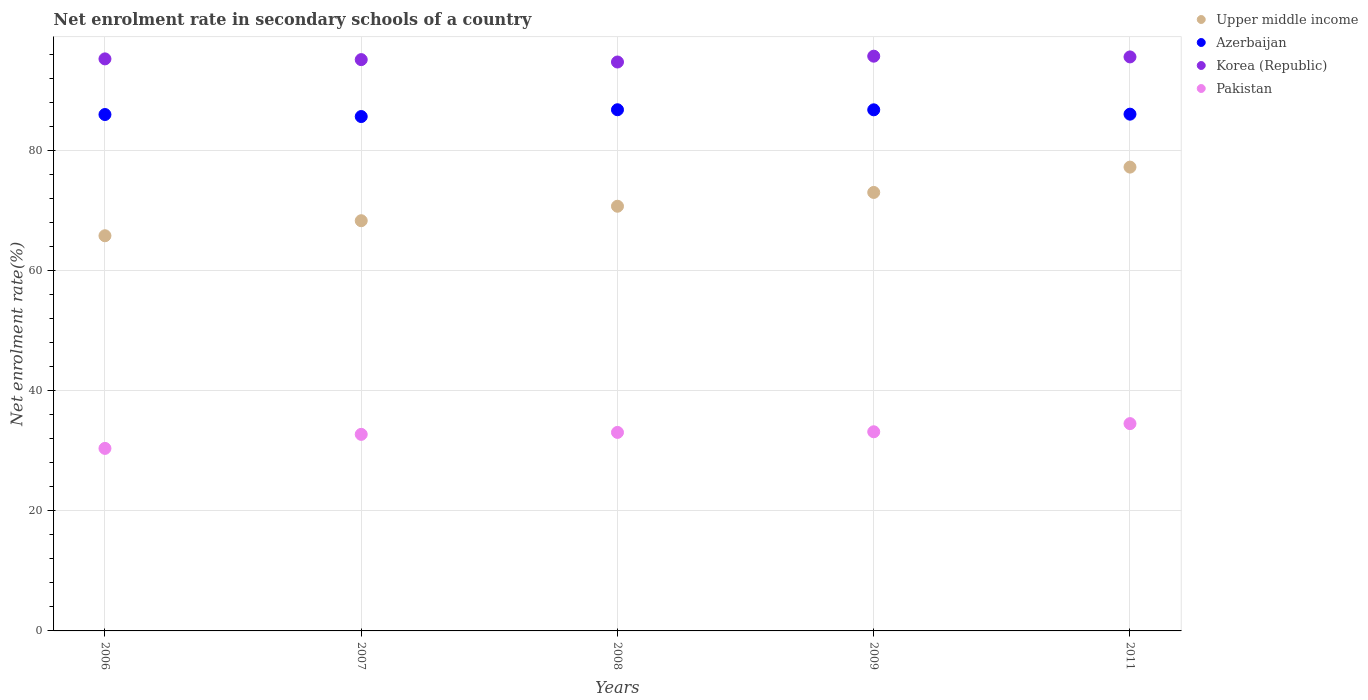Is the number of dotlines equal to the number of legend labels?
Make the answer very short. Yes. What is the net enrolment rate in secondary schools in Korea (Republic) in 2006?
Your answer should be compact. 95.28. Across all years, what is the maximum net enrolment rate in secondary schools in Korea (Republic)?
Your response must be concise. 95.73. Across all years, what is the minimum net enrolment rate in secondary schools in Upper middle income?
Ensure brevity in your answer.  65.82. In which year was the net enrolment rate in secondary schools in Pakistan maximum?
Give a very brief answer. 2011. What is the total net enrolment rate in secondary schools in Azerbaijan in the graph?
Provide a short and direct response. 431.38. What is the difference between the net enrolment rate in secondary schools in Pakistan in 2008 and that in 2011?
Ensure brevity in your answer.  -1.46. What is the difference between the net enrolment rate in secondary schools in Pakistan in 2011 and the net enrolment rate in secondary schools in Korea (Republic) in 2008?
Your response must be concise. -60.23. What is the average net enrolment rate in secondary schools in Azerbaijan per year?
Provide a short and direct response. 86.28. In the year 2006, what is the difference between the net enrolment rate in secondary schools in Upper middle income and net enrolment rate in secondary schools in Pakistan?
Your response must be concise. 35.42. What is the ratio of the net enrolment rate in secondary schools in Upper middle income in 2008 to that in 2011?
Provide a short and direct response. 0.92. What is the difference between the highest and the second highest net enrolment rate in secondary schools in Upper middle income?
Provide a succinct answer. 4.22. What is the difference between the highest and the lowest net enrolment rate in secondary schools in Azerbaijan?
Give a very brief answer. 1.13. Is it the case that in every year, the sum of the net enrolment rate in secondary schools in Pakistan and net enrolment rate in secondary schools in Upper middle income  is greater than the sum of net enrolment rate in secondary schools in Korea (Republic) and net enrolment rate in secondary schools in Azerbaijan?
Your answer should be compact. Yes. Is it the case that in every year, the sum of the net enrolment rate in secondary schools in Upper middle income and net enrolment rate in secondary schools in Korea (Republic)  is greater than the net enrolment rate in secondary schools in Pakistan?
Give a very brief answer. Yes. How many years are there in the graph?
Ensure brevity in your answer.  5. What is the difference between two consecutive major ticks on the Y-axis?
Provide a succinct answer. 20. Does the graph contain any zero values?
Offer a terse response. No. Does the graph contain grids?
Your answer should be compact. Yes. How are the legend labels stacked?
Provide a succinct answer. Vertical. What is the title of the graph?
Offer a very short reply. Net enrolment rate in secondary schools of a country. Does "Malawi" appear as one of the legend labels in the graph?
Your answer should be compact. No. What is the label or title of the Y-axis?
Make the answer very short. Net enrolment rate(%). What is the Net enrolment rate(%) of Upper middle income in 2006?
Your answer should be very brief. 65.82. What is the Net enrolment rate(%) in Azerbaijan in 2006?
Give a very brief answer. 86.02. What is the Net enrolment rate(%) in Korea (Republic) in 2006?
Give a very brief answer. 95.28. What is the Net enrolment rate(%) of Pakistan in 2006?
Give a very brief answer. 30.4. What is the Net enrolment rate(%) of Upper middle income in 2007?
Keep it short and to the point. 68.33. What is the Net enrolment rate(%) in Azerbaijan in 2007?
Keep it short and to the point. 85.68. What is the Net enrolment rate(%) of Korea (Republic) in 2007?
Give a very brief answer. 95.16. What is the Net enrolment rate(%) in Pakistan in 2007?
Offer a very short reply. 32.74. What is the Net enrolment rate(%) in Upper middle income in 2008?
Offer a terse response. 70.74. What is the Net enrolment rate(%) of Azerbaijan in 2008?
Ensure brevity in your answer.  86.81. What is the Net enrolment rate(%) of Korea (Republic) in 2008?
Offer a terse response. 94.76. What is the Net enrolment rate(%) in Pakistan in 2008?
Your answer should be compact. 33.06. What is the Net enrolment rate(%) of Upper middle income in 2009?
Offer a terse response. 73.04. What is the Net enrolment rate(%) in Azerbaijan in 2009?
Provide a short and direct response. 86.8. What is the Net enrolment rate(%) of Korea (Republic) in 2009?
Your answer should be very brief. 95.73. What is the Net enrolment rate(%) of Pakistan in 2009?
Give a very brief answer. 33.17. What is the Net enrolment rate(%) in Upper middle income in 2011?
Ensure brevity in your answer.  77.26. What is the Net enrolment rate(%) of Azerbaijan in 2011?
Offer a terse response. 86.07. What is the Net enrolment rate(%) of Korea (Republic) in 2011?
Provide a succinct answer. 95.61. What is the Net enrolment rate(%) of Pakistan in 2011?
Your response must be concise. 34.53. Across all years, what is the maximum Net enrolment rate(%) in Upper middle income?
Your response must be concise. 77.26. Across all years, what is the maximum Net enrolment rate(%) of Azerbaijan?
Your answer should be very brief. 86.81. Across all years, what is the maximum Net enrolment rate(%) in Korea (Republic)?
Keep it short and to the point. 95.73. Across all years, what is the maximum Net enrolment rate(%) of Pakistan?
Ensure brevity in your answer.  34.53. Across all years, what is the minimum Net enrolment rate(%) of Upper middle income?
Your answer should be compact. 65.82. Across all years, what is the minimum Net enrolment rate(%) in Azerbaijan?
Make the answer very short. 85.68. Across all years, what is the minimum Net enrolment rate(%) of Korea (Republic)?
Your response must be concise. 94.76. Across all years, what is the minimum Net enrolment rate(%) of Pakistan?
Your answer should be very brief. 30.4. What is the total Net enrolment rate(%) in Upper middle income in the graph?
Offer a very short reply. 355.18. What is the total Net enrolment rate(%) of Azerbaijan in the graph?
Make the answer very short. 431.38. What is the total Net enrolment rate(%) of Korea (Republic) in the graph?
Your answer should be very brief. 476.55. What is the total Net enrolment rate(%) of Pakistan in the graph?
Keep it short and to the point. 163.91. What is the difference between the Net enrolment rate(%) of Upper middle income in 2006 and that in 2007?
Offer a terse response. -2.5. What is the difference between the Net enrolment rate(%) in Azerbaijan in 2006 and that in 2007?
Provide a short and direct response. 0.34. What is the difference between the Net enrolment rate(%) in Korea (Republic) in 2006 and that in 2007?
Give a very brief answer. 0.12. What is the difference between the Net enrolment rate(%) in Pakistan in 2006 and that in 2007?
Offer a very short reply. -2.34. What is the difference between the Net enrolment rate(%) of Upper middle income in 2006 and that in 2008?
Offer a very short reply. -4.92. What is the difference between the Net enrolment rate(%) of Azerbaijan in 2006 and that in 2008?
Your answer should be very brief. -0.79. What is the difference between the Net enrolment rate(%) in Korea (Republic) in 2006 and that in 2008?
Offer a very short reply. 0.52. What is the difference between the Net enrolment rate(%) in Pakistan in 2006 and that in 2008?
Provide a succinct answer. -2.66. What is the difference between the Net enrolment rate(%) of Upper middle income in 2006 and that in 2009?
Offer a very short reply. -7.21. What is the difference between the Net enrolment rate(%) of Azerbaijan in 2006 and that in 2009?
Ensure brevity in your answer.  -0.78. What is the difference between the Net enrolment rate(%) of Korea (Republic) in 2006 and that in 2009?
Your answer should be very brief. -0.45. What is the difference between the Net enrolment rate(%) of Pakistan in 2006 and that in 2009?
Your answer should be very brief. -2.77. What is the difference between the Net enrolment rate(%) in Upper middle income in 2006 and that in 2011?
Your response must be concise. -11.43. What is the difference between the Net enrolment rate(%) of Azerbaijan in 2006 and that in 2011?
Offer a very short reply. -0.06. What is the difference between the Net enrolment rate(%) in Korea (Republic) in 2006 and that in 2011?
Offer a very short reply. -0.33. What is the difference between the Net enrolment rate(%) in Pakistan in 2006 and that in 2011?
Make the answer very short. -4.13. What is the difference between the Net enrolment rate(%) of Upper middle income in 2007 and that in 2008?
Ensure brevity in your answer.  -2.41. What is the difference between the Net enrolment rate(%) in Azerbaijan in 2007 and that in 2008?
Provide a succinct answer. -1.13. What is the difference between the Net enrolment rate(%) in Korea (Republic) in 2007 and that in 2008?
Give a very brief answer. 0.4. What is the difference between the Net enrolment rate(%) in Pakistan in 2007 and that in 2008?
Your response must be concise. -0.33. What is the difference between the Net enrolment rate(%) in Upper middle income in 2007 and that in 2009?
Offer a very short reply. -4.71. What is the difference between the Net enrolment rate(%) in Azerbaijan in 2007 and that in 2009?
Your response must be concise. -1.12. What is the difference between the Net enrolment rate(%) in Korea (Republic) in 2007 and that in 2009?
Keep it short and to the point. -0.57. What is the difference between the Net enrolment rate(%) of Pakistan in 2007 and that in 2009?
Offer a very short reply. -0.43. What is the difference between the Net enrolment rate(%) in Upper middle income in 2007 and that in 2011?
Ensure brevity in your answer.  -8.93. What is the difference between the Net enrolment rate(%) of Azerbaijan in 2007 and that in 2011?
Make the answer very short. -0.4. What is the difference between the Net enrolment rate(%) in Korea (Republic) in 2007 and that in 2011?
Ensure brevity in your answer.  -0.45. What is the difference between the Net enrolment rate(%) of Pakistan in 2007 and that in 2011?
Your answer should be very brief. -1.79. What is the difference between the Net enrolment rate(%) in Upper middle income in 2008 and that in 2009?
Your answer should be compact. -2.3. What is the difference between the Net enrolment rate(%) of Azerbaijan in 2008 and that in 2009?
Offer a terse response. 0.01. What is the difference between the Net enrolment rate(%) of Korea (Republic) in 2008 and that in 2009?
Your answer should be very brief. -0.97. What is the difference between the Net enrolment rate(%) in Pakistan in 2008 and that in 2009?
Your response must be concise. -0.11. What is the difference between the Net enrolment rate(%) in Upper middle income in 2008 and that in 2011?
Provide a succinct answer. -6.52. What is the difference between the Net enrolment rate(%) in Azerbaijan in 2008 and that in 2011?
Your response must be concise. 0.74. What is the difference between the Net enrolment rate(%) in Korea (Republic) in 2008 and that in 2011?
Offer a terse response. -0.85. What is the difference between the Net enrolment rate(%) in Pakistan in 2008 and that in 2011?
Your answer should be compact. -1.46. What is the difference between the Net enrolment rate(%) of Upper middle income in 2009 and that in 2011?
Offer a terse response. -4.22. What is the difference between the Net enrolment rate(%) of Azerbaijan in 2009 and that in 2011?
Provide a short and direct response. 0.72. What is the difference between the Net enrolment rate(%) of Korea (Republic) in 2009 and that in 2011?
Give a very brief answer. 0.12. What is the difference between the Net enrolment rate(%) in Pakistan in 2009 and that in 2011?
Your answer should be compact. -1.36. What is the difference between the Net enrolment rate(%) in Upper middle income in 2006 and the Net enrolment rate(%) in Azerbaijan in 2007?
Your answer should be compact. -19.86. What is the difference between the Net enrolment rate(%) of Upper middle income in 2006 and the Net enrolment rate(%) of Korea (Republic) in 2007?
Your response must be concise. -29.34. What is the difference between the Net enrolment rate(%) of Upper middle income in 2006 and the Net enrolment rate(%) of Pakistan in 2007?
Offer a terse response. 33.08. What is the difference between the Net enrolment rate(%) of Azerbaijan in 2006 and the Net enrolment rate(%) of Korea (Republic) in 2007?
Provide a short and direct response. -9.14. What is the difference between the Net enrolment rate(%) in Azerbaijan in 2006 and the Net enrolment rate(%) in Pakistan in 2007?
Provide a succinct answer. 53.28. What is the difference between the Net enrolment rate(%) in Korea (Republic) in 2006 and the Net enrolment rate(%) in Pakistan in 2007?
Give a very brief answer. 62.54. What is the difference between the Net enrolment rate(%) of Upper middle income in 2006 and the Net enrolment rate(%) of Azerbaijan in 2008?
Offer a terse response. -20.99. What is the difference between the Net enrolment rate(%) in Upper middle income in 2006 and the Net enrolment rate(%) in Korea (Republic) in 2008?
Keep it short and to the point. -28.94. What is the difference between the Net enrolment rate(%) of Upper middle income in 2006 and the Net enrolment rate(%) of Pakistan in 2008?
Ensure brevity in your answer.  32.76. What is the difference between the Net enrolment rate(%) in Azerbaijan in 2006 and the Net enrolment rate(%) in Korea (Republic) in 2008?
Give a very brief answer. -8.75. What is the difference between the Net enrolment rate(%) of Azerbaijan in 2006 and the Net enrolment rate(%) of Pakistan in 2008?
Make the answer very short. 52.95. What is the difference between the Net enrolment rate(%) in Korea (Republic) in 2006 and the Net enrolment rate(%) in Pakistan in 2008?
Provide a succinct answer. 62.22. What is the difference between the Net enrolment rate(%) in Upper middle income in 2006 and the Net enrolment rate(%) in Azerbaijan in 2009?
Provide a succinct answer. -20.98. What is the difference between the Net enrolment rate(%) in Upper middle income in 2006 and the Net enrolment rate(%) in Korea (Republic) in 2009?
Provide a short and direct response. -29.91. What is the difference between the Net enrolment rate(%) in Upper middle income in 2006 and the Net enrolment rate(%) in Pakistan in 2009?
Your answer should be very brief. 32.65. What is the difference between the Net enrolment rate(%) in Azerbaijan in 2006 and the Net enrolment rate(%) in Korea (Republic) in 2009?
Ensure brevity in your answer.  -9.72. What is the difference between the Net enrolment rate(%) of Azerbaijan in 2006 and the Net enrolment rate(%) of Pakistan in 2009?
Provide a succinct answer. 52.84. What is the difference between the Net enrolment rate(%) of Korea (Republic) in 2006 and the Net enrolment rate(%) of Pakistan in 2009?
Keep it short and to the point. 62.11. What is the difference between the Net enrolment rate(%) in Upper middle income in 2006 and the Net enrolment rate(%) in Azerbaijan in 2011?
Give a very brief answer. -20.25. What is the difference between the Net enrolment rate(%) of Upper middle income in 2006 and the Net enrolment rate(%) of Korea (Republic) in 2011?
Make the answer very short. -29.79. What is the difference between the Net enrolment rate(%) in Upper middle income in 2006 and the Net enrolment rate(%) in Pakistan in 2011?
Provide a short and direct response. 31.29. What is the difference between the Net enrolment rate(%) of Azerbaijan in 2006 and the Net enrolment rate(%) of Korea (Republic) in 2011?
Offer a terse response. -9.59. What is the difference between the Net enrolment rate(%) in Azerbaijan in 2006 and the Net enrolment rate(%) in Pakistan in 2011?
Keep it short and to the point. 51.49. What is the difference between the Net enrolment rate(%) in Korea (Republic) in 2006 and the Net enrolment rate(%) in Pakistan in 2011?
Your answer should be very brief. 60.75. What is the difference between the Net enrolment rate(%) of Upper middle income in 2007 and the Net enrolment rate(%) of Azerbaijan in 2008?
Your response must be concise. -18.48. What is the difference between the Net enrolment rate(%) of Upper middle income in 2007 and the Net enrolment rate(%) of Korea (Republic) in 2008?
Your answer should be very brief. -26.44. What is the difference between the Net enrolment rate(%) of Upper middle income in 2007 and the Net enrolment rate(%) of Pakistan in 2008?
Your answer should be very brief. 35.26. What is the difference between the Net enrolment rate(%) in Azerbaijan in 2007 and the Net enrolment rate(%) in Korea (Republic) in 2008?
Offer a terse response. -9.08. What is the difference between the Net enrolment rate(%) of Azerbaijan in 2007 and the Net enrolment rate(%) of Pakistan in 2008?
Provide a succinct answer. 52.61. What is the difference between the Net enrolment rate(%) of Korea (Republic) in 2007 and the Net enrolment rate(%) of Pakistan in 2008?
Your answer should be very brief. 62.1. What is the difference between the Net enrolment rate(%) of Upper middle income in 2007 and the Net enrolment rate(%) of Azerbaijan in 2009?
Provide a short and direct response. -18.47. What is the difference between the Net enrolment rate(%) in Upper middle income in 2007 and the Net enrolment rate(%) in Korea (Republic) in 2009?
Your answer should be very brief. -27.41. What is the difference between the Net enrolment rate(%) in Upper middle income in 2007 and the Net enrolment rate(%) in Pakistan in 2009?
Your answer should be very brief. 35.16. What is the difference between the Net enrolment rate(%) of Azerbaijan in 2007 and the Net enrolment rate(%) of Korea (Republic) in 2009?
Offer a very short reply. -10.05. What is the difference between the Net enrolment rate(%) of Azerbaijan in 2007 and the Net enrolment rate(%) of Pakistan in 2009?
Your response must be concise. 52.51. What is the difference between the Net enrolment rate(%) of Korea (Republic) in 2007 and the Net enrolment rate(%) of Pakistan in 2009?
Offer a very short reply. 61.99. What is the difference between the Net enrolment rate(%) in Upper middle income in 2007 and the Net enrolment rate(%) in Azerbaijan in 2011?
Give a very brief answer. -17.75. What is the difference between the Net enrolment rate(%) in Upper middle income in 2007 and the Net enrolment rate(%) in Korea (Republic) in 2011?
Offer a terse response. -27.28. What is the difference between the Net enrolment rate(%) in Upper middle income in 2007 and the Net enrolment rate(%) in Pakistan in 2011?
Keep it short and to the point. 33.8. What is the difference between the Net enrolment rate(%) of Azerbaijan in 2007 and the Net enrolment rate(%) of Korea (Republic) in 2011?
Make the answer very short. -9.93. What is the difference between the Net enrolment rate(%) in Azerbaijan in 2007 and the Net enrolment rate(%) in Pakistan in 2011?
Your answer should be compact. 51.15. What is the difference between the Net enrolment rate(%) in Korea (Republic) in 2007 and the Net enrolment rate(%) in Pakistan in 2011?
Your answer should be very brief. 60.63. What is the difference between the Net enrolment rate(%) in Upper middle income in 2008 and the Net enrolment rate(%) in Azerbaijan in 2009?
Your answer should be compact. -16.06. What is the difference between the Net enrolment rate(%) of Upper middle income in 2008 and the Net enrolment rate(%) of Korea (Republic) in 2009?
Ensure brevity in your answer.  -24.99. What is the difference between the Net enrolment rate(%) in Upper middle income in 2008 and the Net enrolment rate(%) in Pakistan in 2009?
Ensure brevity in your answer.  37.57. What is the difference between the Net enrolment rate(%) in Azerbaijan in 2008 and the Net enrolment rate(%) in Korea (Republic) in 2009?
Offer a terse response. -8.92. What is the difference between the Net enrolment rate(%) in Azerbaijan in 2008 and the Net enrolment rate(%) in Pakistan in 2009?
Keep it short and to the point. 53.64. What is the difference between the Net enrolment rate(%) in Korea (Republic) in 2008 and the Net enrolment rate(%) in Pakistan in 2009?
Provide a succinct answer. 61.59. What is the difference between the Net enrolment rate(%) of Upper middle income in 2008 and the Net enrolment rate(%) of Azerbaijan in 2011?
Offer a terse response. -15.34. What is the difference between the Net enrolment rate(%) in Upper middle income in 2008 and the Net enrolment rate(%) in Korea (Republic) in 2011?
Offer a terse response. -24.87. What is the difference between the Net enrolment rate(%) of Upper middle income in 2008 and the Net enrolment rate(%) of Pakistan in 2011?
Provide a succinct answer. 36.21. What is the difference between the Net enrolment rate(%) of Azerbaijan in 2008 and the Net enrolment rate(%) of Korea (Republic) in 2011?
Offer a very short reply. -8.8. What is the difference between the Net enrolment rate(%) in Azerbaijan in 2008 and the Net enrolment rate(%) in Pakistan in 2011?
Offer a terse response. 52.28. What is the difference between the Net enrolment rate(%) in Korea (Republic) in 2008 and the Net enrolment rate(%) in Pakistan in 2011?
Give a very brief answer. 60.23. What is the difference between the Net enrolment rate(%) of Upper middle income in 2009 and the Net enrolment rate(%) of Azerbaijan in 2011?
Ensure brevity in your answer.  -13.04. What is the difference between the Net enrolment rate(%) of Upper middle income in 2009 and the Net enrolment rate(%) of Korea (Republic) in 2011?
Offer a terse response. -22.57. What is the difference between the Net enrolment rate(%) of Upper middle income in 2009 and the Net enrolment rate(%) of Pakistan in 2011?
Offer a terse response. 38.51. What is the difference between the Net enrolment rate(%) in Azerbaijan in 2009 and the Net enrolment rate(%) in Korea (Republic) in 2011?
Your answer should be compact. -8.81. What is the difference between the Net enrolment rate(%) in Azerbaijan in 2009 and the Net enrolment rate(%) in Pakistan in 2011?
Keep it short and to the point. 52.27. What is the difference between the Net enrolment rate(%) in Korea (Republic) in 2009 and the Net enrolment rate(%) in Pakistan in 2011?
Provide a succinct answer. 61.2. What is the average Net enrolment rate(%) of Upper middle income per year?
Make the answer very short. 71.04. What is the average Net enrolment rate(%) of Azerbaijan per year?
Offer a very short reply. 86.28. What is the average Net enrolment rate(%) in Korea (Republic) per year?
Offer a terse response. 95.31. What is the average Net enrolment rate(%) in Pakistan per year?
Ensure brevity in your answer.  32.78. In the year 2006, what is the difference between the Net enrolment rate(%) of Upper middle income and Net enrolment rate(%) of Azerbaijan?
Provide a short and direct response. -20.19. In the year 2006, what is the difference between the Net enrolment rate(%) of Upper middle income and Net enrolment rate(%) of Korea (Republic)?
Keep it short and to the point. -29.46. In the year 2006, what is the difference between the Net enrolment rate(%) in Upper middle income and Net enrolment rate(%) in Pakistan?
Your answer should be compact. 35.42. In the year 2006, what is the difference between the Net enrolment rate(%) in Azerbaijan and Net enrolment rate(%) in Korea (Republic)?
Keep it short and to the point. -9.27. In the year 2006, what is the difference between the Net enrolment rate(%) of Azerbaijan and Net enrolment rate(%) of Pakistan?
Your answer should be very brief. 55.61. In the year 2006, what is the difference between the Net enrolment rate(%) in Korea (Republic) and Net enrolment rate(%) in Pakistan?
Provide a succinct answer. 64.88. In the year 2007, what is the difference between the Net enrolment rate(%) in Upper middle income and Net enrolment rate(%) in Azerbaijan?
Your response must be concise. -17.35. In the year 2007, what is the difference between the Net enrolment rate(%) in Upper middle income and Net enrolment rate(%) in Korea (Republic)?
Your answer should be compact. -26.83. In the year 2007, what is the difference between the Net enrolment rate(%) of Upper middle income and Net enrolment rate(%) of Pakistan?
Provide a succinct answer. 35.59. In the year 2007, what is the difference between the Net enrolment rate(%) of Azerbaijan and Net enrolment rate(%) of Korea (Republic)?
Your answer should be very brief. -9.48. In the year 2007, what is the difference between the Net enrolment rate(%) of Azerbaijan and Net enrolment rate(%) of Pakistan?
Offer a terse response. 52.94. In the year 2007, what is the difference between the Net enrolment rate(%) in Korea (Republic) and Net enrolment rate(%) in Pakistan?
Provide a short and direct response. 62.42. In the year 2008, what is the difference between the Net enrolment rate(%) in Upper middle income and Net enrolment rate(%) in Azerbaijan?
Make the answer very short. -16.07. In the year 2008, what is the difference between the Net enrolment rate(%) of Upper middle income and Net enrolment rate(%) of Korea (Republic)?
Ensure brevity in your answer.  -24.02. In the year 2008, what is the difference between the Net enrolment rate(%) of Upper middle income and Net enrolment rate(%) of Pakistan?
Give a very brief answer. 37.67. In the year 2008, what is the difference between the Net enrolment rate(%) of Azerbaijan and Net enrolment rate(%) of Korea (Republic)?
Your answer should be compact. -7.95. In the year 2008, what is the difference between the Net enrolment rate(%) in Azerbaijan and Net enrolment rate(%) in Pakistan?
Give a very brief answer. 53.75. In the year 2008, what is the difference between the Net enrolment rate(%) in Korea (Republic) and Net enrolment rate(%) in Pakistan?
Your answer should be compact. 61.7. In the year 2009, what is the difference between the Net enrolment rate(%) of Upper middle income and Net enrolment rate(%) of Azerbaijan?
Ensure brevity in your answer.  -13.76. In the year 2009, what is the difference between the Net enrolment rate(%) in Upper middle income and Net enrolment rate(%) in Korea (Republic)?
Provide a short and direct response. -22.7. In the year 2009, what is the difference between the Net enrolment rate(%) of Upper middle income and Net enrolment rate(%) of Pakistan?
Keep it short and to the point. 39.87. In the year 2009, what is the difference between the Net enrolment rate(%) in Azerbaijan and Net enrolment rate(%) in Korea (Republic)?
Offer a very short reply. -8.93. In the year 2009, what is the difference between the Net enrolment rate(%) of Azerbaijan and Net enrolment rate(%) of Pakistan?
Give a very brief answer. 53.63. In the year 2009, what is the difference between the Net enrolment rate(%) of Korea (Republic) and Net enrolment rate(%) of Pakistan?
Your response must be concise. 62.56. In the year 2011, what is the difference between the Net enrolment rate(%) of Upper middle income and Net enrolment rate(%) of Azerbaijan?
Keep it short and to the point. -8.82. In the year 2011, what is the difference between the Net enrolment rate(%) in Upper middle income and Net enrolment rate(%) in Korea (Republic)?
Provide a short and direct response. -18.35. In the year 2011, what is the difference between the Net enrolment rate(%) in Upper middle income and Net enrolment rate(%) in Pakistan?
Provide a succinct answer. 42.73. In the year 2011, what is the difference between the Net enrolment rate(%) of Azerbaijan and Net enrolment rate(%) of Korea (Republic)?
Make the answer very short. -9.54. In the year 2011, what is the difference between the Net enrolment rate(%) in Azerbaijan and Net enrolment rate(%) in Pakistan?
Your answer should be very brief. 51.55. In the year 2011, what is the difference between the Net enrolment rate(%) in Korea (Republic) and Net enrolment rate(%) in Pakistan?
Your answer should be very brief. 61.08. What is the ratio of the Net enrolment rate(%) in Upper middle income in 2006 to that in 2007?
Give a very brief answer. 0.96. What is the ratio of the Net enrolment rate(%) in Korea (Republic) in 2006 to that in 2007?
Your answer should be compact. 1. What is the ratio of the Net enrolment rate(%) in Upper middle income in 2006 to that in 2008?
Offer a very short reply. 0.93. What is the ratio of the Net enrolment rate(%) of Pakistan in 2006 to that in 2008?
Make the answer very short. 0.92. What is the ratio of the Net enrolment rate(%) in Upper middle income in 2006 to that in 2009?
Give a very brief answer. 0.9. What is the ratio of the Net enrolment rate(%) in Korea (Republic) in 2006 to that in 2009?
Give a very brief answer. 1. What is the ratio of the Net enrolment rate(%) of Pakistan in 2006 to that in 2009?
Your answer should be compact. 0.92. What is the ratio of the Net enrolment rate(%) of Upper middle income in 2006 to that in 2011?
Provide a succinct answer. 0.85. What is the ratio of the Net enrolment rate(%) in Azerbaijan in 2006 to that in 2011?
Give a very brief answer. 1. What is the ratio of the Net enrolment rate(%) of Pakistan in 2006 to that in 2011?
Keep it short and to the point. 0.88. What is the ratio of the Net enrolment rate(%) in Upper middle income in 2007 to that in 2008?
Your answer should be very brief. 0.97. What is the ratio of the Net enrolment rate(%) of Azerbaijan in 2007 to that in 2008?
Provide a short and direct response. 0.99. What is the ratio of the Net enrolment rate(%) of Korea (Republic) in 2007 to that in 2008?
Make the answer very short. 1. What is the ratio of the Net enrolment rate(%) in Pakistan in 2007 to that in 2008?
Your answer should be very brief. 0.99. What is the ratio of the Net enrolment rate(%) in Upper middle income in 2007 to that in 2009?
Give a very brief answer. 0.94. What is the ratio of the Net enrolment rate(%) in Azerbaijan in 2007 to that in 2009?
Offer a very short reply. 0.99. What is the ratio of the Net enrolment rate(%) in Upper middle income in 2007 to that in 2011?
Offer a very short reply. 0.88. What is the ratio of the Net enrolment rate(%) of Azerbaijan in 2007 to that in 2011?
Offer a terse response. 1. What is the ratio of the Net enrolment rate(%) in Korea (Republic) in 2007 to that in 2011?
Make the answer very short. 1. What is the ratio of the Net enrolment rate(%) of Pakistan in 2007 to that in 2011?
Make the answer very short. 0.95. What is the ratio of the Net enrolment rate(%) of Upper middle income in 2008 to that in 2009?
Your response must be concise. 0.97. What is the ratio of the Net enrolment rate(%) in Korea (Republic) in 2008 to that in 2009?
Provide a short and direct response. 0.99. What is the ratio of the Net enrolment rate(%) in Upper middle income in 2008 to that in 2011?
Provide a succinct answer. 0.92. What is the ratio of the Net enrolment rate(%) of Azerbaijan in 2008 to that in 2011?
Your answer should be very brief. 1.01. What is the ratio of the Net enrolment rate(%) of Pakistan in 2008 to that in 2011?
Offer a terse response. 0.96. What is the ratio of the Net enrolment rate(%) in Upper middle income in 2009 to that in 2011?
Make the answer very short. 0.95. What is the ratio of the Net enrolment rate(%) in Azerbaijan in 2009 to that in 2011?
Make the answer very short. 1.01. What is the ratio of the Net enrolment rate(%) of Pakistan in 2009 to that in 2011?
Make the answer very short. 0.96. What is the difference between the highest and the second highest Net enrolment rate(%) of Upper middle income?
Your answer should be very brief. 4.22. What is the difference between the highest and the second highest Net enrolment rate(%) in Azerbaijan?
Keep it short and to the point. 0.01. What is the difference between the highest and the second highest Net enrolment rate(%) in Korea (Republic)?
Make the answer very short. 0.12. What is the difference between the highest and the second highest Net enrolment rate(%) of Pakistan?
Give a very brief answer. 1.36. What is the difference between the highest and the lowest Net enrolment rate(%) of Upper middle income?
Make the answer very short. 11.43. What is the difference between the highest and the lowest Net enrolment rate(%) of Azerbaijan?
Provide a short and direct response. 1.13. What is the difference between the highest and the lowest Net enrolment rate(%) in Pakistan?
Your response must be concise. 4.13. 